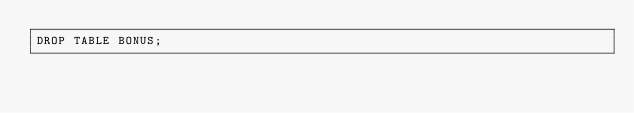<code> <loc_0><loc_0><loc_500><loc_500><_SQL_>DROP TABLE BONUS;</code> 